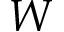<formula> <loc_0><loc_0><loc_500><loc_500>W</formula> 